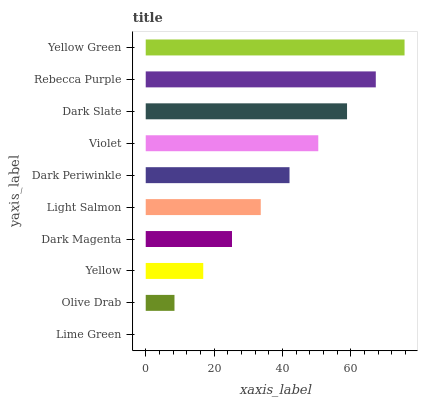Is Lime Green the minimum?
Answer yes or no. Yes. Is Yellow Green the maximum?
Answer yes or no. Yes. Is Olive Drab the minimum?
Answer yes or no. No. Is Olive Drab the maximum?
Answer yes or no. No. Is Olive Drab greater than Lime Green?
Answer yes or no. Yes. Is Lime Green less than Olive Drab?
Answer yes or no. Yes. Is Lime Green greater than Olive Drab?
Answer yes or no. No. Is Olive Drab less than Lime Green?
Answer yes or no. No. Is Dark Periwinkle the high median?
Answer yes or no. Yes. Is Light Salmon the low median?
Answer yes or no. Yes. Is Dark Slate the high median?
Answer yes or no. No. Is Dark Slate the low median?
Answer yes or no. No. 